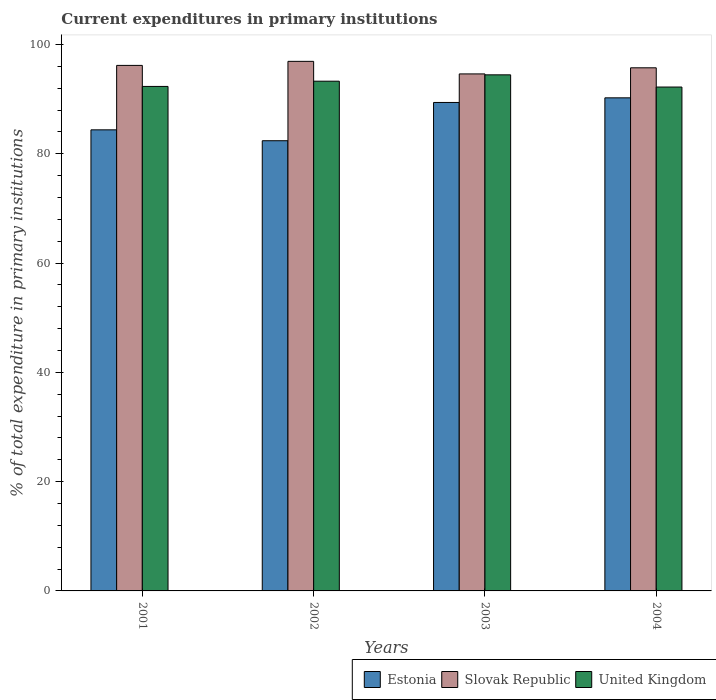How many different coloured bars are there?
Your answer should be compact. 3. How many groups of bars are there?
Your answer should be compact. 4. How many bars are there on the 1st tick from the left?
Your response must be concise. 3. How many bars are there on the 3rd tick from the right?
Offer a very short reply. 3. What is the label of the 4th group of bars from the left?
Your response must be concise. 2004. In how many cases, is the number of bars for a given year not equal to the number of legend labels?
Provide a succinct answer. 0. What is the current expenditures in primary institutions in United Kingdom in 2004?
Keep it short and to the point. 92.21. Across all years, what is the maximum current expenditures in primary institutions in Estonia?
Make the answer very short. 90.24. Across all years, what is the minimum current expenditures in primary institutions in United Kingdom?
Provide a short and direct response. 92.21. In which year was the current expenditures in primary institutions in Estonia maximum?
Keep it short and to the point. 2004. What is the total current expenditures in primary institutions in United Kingdom in the graph?
Offer a terse response. 372.26. What is the difference between the current expenditures in primary institutions in United Kingdom in 2001 and that in 2003?
Make the answer very short. -2.12. What is the difference between the current expenditures in primary institutions in Slovak Republic in 2001 and the current expenditures in primary institutions in United Kingdom in 2002?
Provide a short and direct response. 2.89. What is the average current expenditures in primary institutions in Estonia per year?
Ensure brevity in your answer.  86.6. In the year 2002, what is the difference between the current expenditures in primary institutions in Estonia and current expenditures in primary institutions in United Kingdom?
Provide a succinct answer. -10.89. What is the ratio of the current expenditures in primary institutions in Slovak Republic in 2001 to that in 2003?
Give a very brief answer. 1.02. Is the current expenditures in primary institutions in United Kingdom in 2003 less than that in 2004?
Offer a terse response. No. What is the difference between the highest and the second highest current expenditures in primary institutions in Estonia?
Ensure brevity in your answer.  0.85. What is the difference between the highest and the lowest current expenditures in primary institutions in United Kingdom?
Provide a short and direct response. 2.23. In how many years, is the current expenditures in primary institutions in Slovak Republic greater than the average current expenditures in primary institutions in Slovak Republic taken over all years?
Offer a very short reply. 2. What does the 2nd bar from the left in 2001 represents?
Your answer should be compact. Slovak Republic. What does the 1st bar from the right in 2003 represents?
Keep it short and to the point. United Kingdom. How many bars are there?
Give a very brief answer. 12. Are all the bars in the graph horizontal?
Provide a succinct answer. No. What is the difference between two consecutive major ticks on the Y-axis?
Keep it short and to the point. 20. Are the values on the major ticks of Y-axis written in scientific E-notation?
Offer a very short reply. No. How many legend labels are there?
Make the answer very short. 3. What is the title of the graph?
Give a very brief answer. Current expenditures in primary institutions. Does "Brazil" appear as one of the legend labels in the graph?
Your answer should be compact. No. What is the label or title of the Y-axis?
Give a very brief answer. % of total expenditure in primary institutions. What is the % of total expenditure in primary institutions in Estonia in 2001?
Your response must be concise. 84.38. What is the % of total expenditure in primary institutions in Slovak Republic in 2001?
Offer a very short reply. 96.17. What is the % of total expenditure in primary institutions of United Kingdom in 2001?
Your answer should be very brief. 92.32. What is the % of total expenditure in primary institutions in Estonia in 2002?
Your answer should be compact. 82.39. What is the % of total expenditure in primary institutions in Slovak Republic in 2002?
Give a very brief answer. 96.91. What is the % of total expenditure in primary institutions of United Kingdom in 2002?
Provide a short and direct response. 93.28. What is the % of total expenditure in primary institutions in Estonia in 2003?
Your answer should be compact. 89.39. What is the % of total expenditure in primary institutions in Slovak Republic in 2003?
Keep it short and to the point. 94.61. What is the % of total expenditure in primary institutions of United Kingdom in 2003?
Ensure brevity in your answer.  94.44. What is the % of total expenditure in primary institutions of Estonia in 2004?
Your answer should be compact. 90.24. What is the % of total expenditure in primary institutions in Slovak Republic in 2004?
Offer a terse response. 95.73. What is the % of total expenditure in primary institutions of United Kingdom in 2004?
Provide a succinct answer. 92.21. Across all years, what is the maximum % of total expenditure in primary institutions of Estonia?
Your answer should be compact. 90.24. Across all years, what is the maximum % of total expenditure in primary institutions of Slovak Republic?
Keep it short and to the point. 96.91. Across all years, what is the maximum % of total expenditure in primary institutions of United Kingdom?
Your answer should be compact. 94.44. Across all years, what is the minimum % of total expenditure in primary institutions of Estonia?
Ensure brevity in your answer.  82.39. Across all years, what is the minimum % of total expenditure in primary institutions of Slovak Republic?
Give a very brief answer. 94.61. Across all years, what is the minimum % of total expenditure in primary institutions of United Kingdom?
Your answer should be very brief. 92.21. What is the total % of total expenditure in primary institutions of Estonia in the graph?
Your answer should be compact. 346.39. What is the total % of total expenditure in primary institutions in Slovak Republic in the graph?
Provide a short and direct response. 383.43. What is the total % of total expenditure in primary institutions of United Kingdom in the graph?
Your answer should be compact. 372.26. What is the difference between the % of total expenditure in primary institutions in Estonia in 2001 and that in 2002?
Provide a succinct answer. 1.99. What is the difference between the % of total expenditure in primary institutions of Slovak Republic in 2001 and that in 2002?
Offer a very short reply. -0.74. What is the difference between the % of total expenditure in primary institutions in United Kingdom in 2001 and that in 2002?
Keep it short and to the point. -0.96. What is the difference between the % of total expenditure in primary institutions in Estonia in 2001 and that in 2003?
Your answer should be compact. -5.01. What is the difference between the % of total expenditure in primary institutions of Slovak Republic in 2001 and that in 2003?
Give a very brief answer. 1.56. What is the difference between the % of total expenditure in primary institutions of United Kingdom in 2001 and that in 2003?
Keep it short and to the point. -2.12. What is the difference between the % of total expenditure in primary institutions of Estonia in 2001 and that in 2004?
Make the answer very short. -5.86. What is the difference between the % of total expenditure in primary institutions of Slovak Republic in 2001 and that in 2004?
Your response must be concise. 0.44. What is the difference between the % of total expenditure in primary institutions of United Kingdom in 2001 and that in 2004?
Your answer should be compact. 0.11. What is the difference between the % of total expenditure in primary institutions in Estonia in 2002 and that in 2003?
Offer a very short reply. -7. What is the difference between the % of total expenditure in primary institutions in Slovak Republic in 2002 and that in 2003?
Ensure brevity in your answer.  2.3. What is the difference between the % of total expenditure in primary institutions of United Kingdom in 2002 and that in 2003?
Your answer should be compact. -1.16. What is the difference between the % of total expenditure in primary institutions in Estonia in 2002 and that in 2004?
Provide a succinct answer. -7.85. What is the difference between the % of total expenditure in primary institutions of Slovak Republic in 2002 and that in 2004?
Your answer should be compact. 1.18. What is the difference between the % of total expenditure in primary institutions of United Kingdom in 2002 and that in 2004?
Offer a terse response. 1.07. What is the difference between the % of total expenditure in primary institutions of Estonia in 2003 and that in 2004?
Your answer should be very brief. -0.85. What is the difference between the % of total expenditure in primary institutions in Slovak Republic in 2003 and that in 2004?
Provide a succinct answer. -1.12. What is the difference between the % of total expenditure in primary institutions in United Kingdom in 2003 and that in 2004?
Give a very brief answer. 2.23. What is the difference between the % of total expenditure in primary institutions in Estonia in 2001 and the % of total expenditure in primary institutions in Slovak Republic in 2002?
Make the answer very short. -12.53. What is the difference between the % of total expenditure in primary institutions of Estonia in 2001 and the % of total expenditure in primary institutions of United Kingdom in 2002?
Offer a very short reply. -8.9. What is the difference between the % of total expenditure in primary institutions in Slovak Republic in 2001 and the % of total expenditure in primary institutions in United Kingdom in 2002?
Offer a terse response. 2.89. What is the difference between the % of total expenditure in primary institutions in Estonia in 2001 and the % of total expenditure in primary institutions in Slovak Republic in 2003?
Keep it short and to the point. -10.23. What is the difference between the % of total expenditure in primary institutions in Estonia in 2001 and the % of total expenditure in primary institutions in United Kingdom in 2003?
Ensure brevity in your answer.  -10.06. What is the difference between the % of total expenditure in primary institutions of Slovak Republic in 2001 and the % of total expenditure in primary institutions of United Kingdom in 2003?
Make the answer very short. 1.73. What is the difference between the % of total expenditure in primary institutions of Estonia in 2001 and the % of total expenditure in primary institutions of Slovak Republic in 2004?
Provide a short and direct response. -11.35. What is the difference between the % of total expenditure in primary institutions in Estonia in 2001 and the % of total expenditure in primary institutions in United Kingdom in 2004?
Make the answer very short. -7.83. What is the difference between the % of total expenditure in primary institutions of Slovak Republic in 2001 and the % of total expenditure in primary institutions of United Kingdom in 2004?
Ensure brevity in your answer.  3.96. What is the difference between the % of total expenditure in primary institutions in Estonia in 2002 and the % of total expenditure in primary institutions in Slovak Republic in 2003?
Ensure brevity in your answer.  -12.23. What is the difference between the % of total expenditure in primary institutions of Estonia in 2002 and the % of total expenditure in primary institutions of United Kingdom in 2003?
Keep it short and to the point. -12.06. What is the difference between the % of total expenditure in primary institutions of Slovak Republic in 2002 and the % of total expenditure in primary institutions of United Kingdom in 2003?
Give a very brief answer. 2.47. What is the difference between the % of total expenditure in primary institutions of Estonia in 2002 and the % of total expenditure in primary institutions of Slovak Republic in 2004?
Offer a terse response. -13.34. What is the difference between the % of total expenditure in primary institutions in Estonia in 2002 and the % of total expenditure in primary institutions in United Kingdom in 2004?
Offer a terse response. -9.82. What is the difference between the % of total expenditure in primary institutions of Slovak Republic in 2002 and the % of total expenditure in primary institutions of United Kingdom in 2004?
Offer a very short reply. 4.7. What is the difference between the % of total expenditure in primary institutions in Estonia in 2003 and the % of total expenditure in primary institutions in Slovak Republic in 2004?
Your answer should be very brief. -6.34. What is the difference between the % of total expenditure in primary institutions of Estonia in 2003 and the % of total expenditure in primary institutions of United Kingdom in 2004?
Keep it short and to the point. -2.82. What is the difference between the % of total expenditure in primary institutions in Slovak Republic in 2003 and the % of total expenditure in primary institutions in United Kingdom in 2004?
Provide a succinct answer. 2.4. What is the average % of total expenditure in primary institutions of Estonia per year?
Your answer should be very brief. 86.6. What is the average % of total expenditure in primary institutions of Slovak Republic per year?
Make the answer very short. 95.86. What is the average % of total expenditure in primary institutions in United Kingdom per year?
Give a very brief answer. 93.06. In the year 2001, what is the difference between the % of total expenditure in primary institutions of Estonia and % of total expenditure in primary institutions of Slovak Republic?
Offer a very short reply. -11.79. In the year 2001, what is the difference between the % of total expenditure in primary institutions of Estonia and % of total expenditure in primary institutions of United Kingdom?
Your answer should be compact. -7.94. In the year 2001, what is the difference between the % of total expenditure in primary institutions of Slovak Republic and % of total expenditure in primary institutions of United Kingdom?
Your answer should be compact. 3.85. In the year 2002, what is the difference between the % of total expenditure in primary institutions in Estonia and % of total expenditure in primary institutions in Slovak Republic?
Ensure brevity in your answer.  -14.52. In the year 2002, what is the difference between the % of total expenditure in primary institutions in Estonia and % of total expenditure in primary institutions in United Kingdom?
Make the answer very short. -10.89. In the year 2002, what is the difference between the % of total expenditure in primary institutions of Slovak Republic and % of total expenditure in primary institutions of United Kingdom?
Make the answer very short. 3.63. In the year 2003, what is the difference between the % of total expenditure in primary institutions of Estonia and % of total expenditure in primary institutions of Slovak Republic?
Keep it short and to the point. -5.22. In the year 2003, what is the difference between the % of total expenditure in primary institutions of Estonia and % of total expenditure in primary institutions of United Kingdom?
Offer a very short reply. -5.05. In the year 2003, what is the difference between the % of total expenditure in primary institutions of Slovak Republic and % of total expenditure in primary institutions of United Kingdom?
Your answer should be very brief. 0.17. In the year 2004, what is the difference between the % of total expenditure in primary institutions of Estonia and % of total expenditure in primary institutions of Slovak Republic?
Offer a very short reply. -5.5. In the year 2004, what is the difference between the % of total expenditure in primary institutions in Estonia and % of total expenditure in primary institutions in United Kingdom?
Provide a succinct answer. -1.97. In the year 2004, what is the difference between the % of total expenditure in primary institutions in Slovak Republic and % of total expenditure in primary institutions in United Kingdom?
Provide a short and direct response. 3.52. What is the ratio of the % of total expenditure in primary institutions in Estonia in 2001 to that in 2002?
Offer a terse response. 1.02. What is the ratio of the % of total expenditure in primary institutions of Estonia in 2001 to that in 2003?
Offer a terse response. 0.94. What is the ratio of the % of total expenditure in primary institutions in Slovak Republic in 2001 to that in 2003?
Provide a short and direct response. 1.02. What is the ratio of the % of total expenditure in primary institutions in United Kingdom in 2001 to that in 2003?
Make the answer very short. 0.98. What is the ratio of the % of total expenditure in primary institutions in Estonia in 2001 to that in 2004?
Offer a terse response. 0.94. What is the ratio of the % of total expenditure in primary institutions in Slovak Republic in 2001 to that in 2004?
Ensure brevity in your answer.  1. What is the ratio of the % of total expenditure in primary institutions of United Kingdom in 2001 to that in 2004?
Make the answer very short. 1. What is the ratio of the % of total expenditure in primary institutions in Estonia in 2002 to that in 2003?
Ensure brevity in your answer.  0.92. What is the ratio of the % of total expenditure in primary institutions in Slovak Republic in 2002 to that in 2003?
Ensure brevity in your answer.  1.02. What is the ratio of the % of total expenditure in primary institutions in United Kingdom in 2002 to that in 2003?
Offer a terse response. 0.99. What is the ratio of the % of total expenditure in primary institutions in Estonia in 2002 to that in 2004?
Your answer should be compact. 0.91. What is the ratio of the % of total expenditure in primary institutions in Slovak Republic in 2002 to that in 2004?
Your answer should be very brief. 1.01. What is the ratio of the % of total expenditure in primary institutions of United Kingdom in 2002 to that in 2004?
Your answer should be compact. 1.01. What is the ratio of the % of total expenditure in primary institutions in Estonia in 2003 to that in 2004?
Give a very brief answer. 0.99. What is the ratio of the % of total expenditure in primary institutions of Slovak Republic in 2003 to that in 2004?
Provide a short and direct response. 0.99. What is the ratio of the % of total expenditure in primary institutions of United Kingdom in 2003 to that in 2004?
Keep it short and to the point. 1.02. What is the difference between the highest and the second highest % of total expenditure in primary institutions in Estonia?
Offer a terse response. 0.85. What is the difference between the highest and the second highest % of total expenditure in primary institutions in Slovak Republic?
Your answer should be very brief. 0.74. What is the difference between the highest and the second highest % of total expenditure in primary institutions of United Kingdom?
Give a very brief answer. 1.16. What is the difference between the highest and the lowest % of total expenditure in primary institutions of Estonia?
Provide a succinct answer. 7.85. What is the difference between the highest and the lowest % of total expenditure in primary institutions of Slovak Republic?
Provide a succinct answer. 2.3. What is the difference between the highest and the lowest % of total expenditure in primary institutions of United Kingdom?
Ensure brevity in your answer.  2.23. 